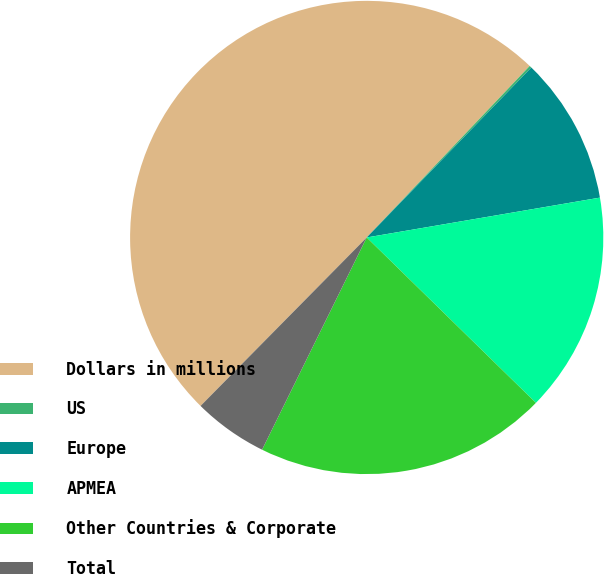Convert chart to OTSL. <chart><loc_0><loc_0><loc_500><loc_500><pie_chart><fcel>Dollars in millions<fcel>US<fcel>Europe<fcel>APMEA<fcel>Other Countries & Corporate<fcel>Total<nl><fcel>49.7%<fcel>0.15%<fcel>10.06%<fcel>15.01%<fcel>19.97%<fcel>5.1%<nl></chart> 